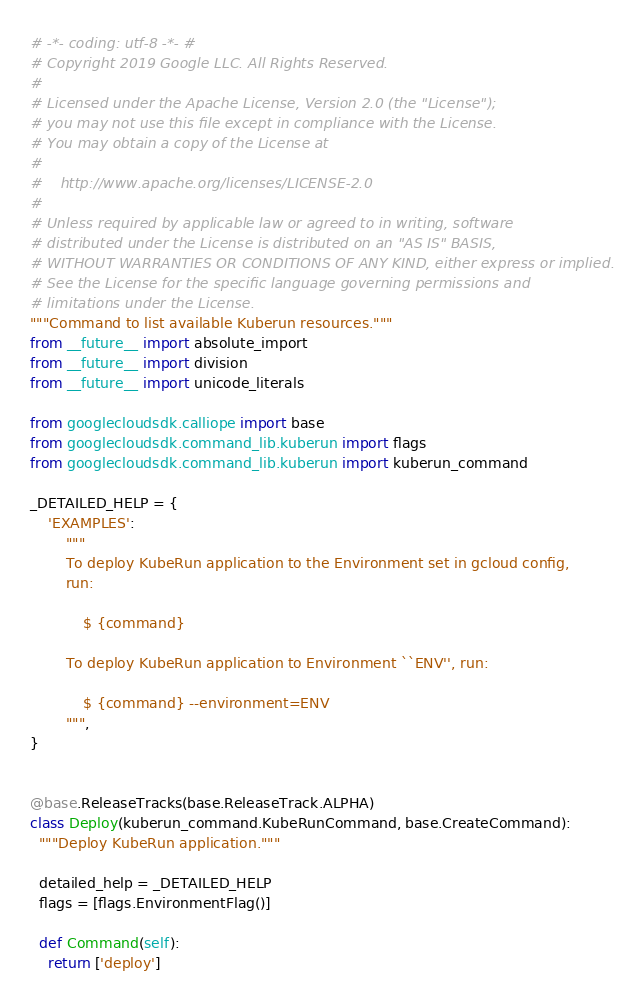<code> <loc_0><loc_0><loc_500><loc_500><_Python_># -*- coding: utf-8 -*- #
# Copyright 2019 Google LLC. All Rights Reserved.
#
# Licensed under the Apache License, Version 2.0 (the "License");
# you may not use this file except in compliance with the License.
# You may obtain a copy of the License at
#
#    http://www.apache.org/licenses/LICENSE-2.0
#
# Unless required by applicable law or agreed to in writing, software
# distributed under the License is distributed on an "AS IS" BASIS,
# WITHOUT WARRANTIES OR CONDITIONS OF ANY KIND, either express or implied.
# See the License for the specific language governing permissions and
# limitations under the License.
"""Command to list available Kuberun resources."""
from __future__ import absolute_import
from __future__ import division
from __future__ import unicode_literals

from googlecloudsdk.calliope import base
from googlecloudsdk.command_lib.kuberun import flags
from googlecloudsdk.command_lib.kuberun import kuberun_command

_DETAILED_HELP = {
    'EXAMPLES':
        """
        To deploy KubeRun application to the Environment set in gcloud config,
        run:

            $ {command}

        To deploy KubeRun application to Environment ``ENV'', run:

            $ {command} --environment=ENV
        """,
}


@base.ReleaseTracks(base.ReleaseTrack.ALPHA)
class Deploy(kuberun_command.KubeRunCommand, base.CreateCommand):
  """Deploy KubeRun application."""

  detailed_help = _DETAILED_HELP
  flags = [flags.EnvironmentFlag()]

  def Command(self):
    return ['deploy']
</code> 